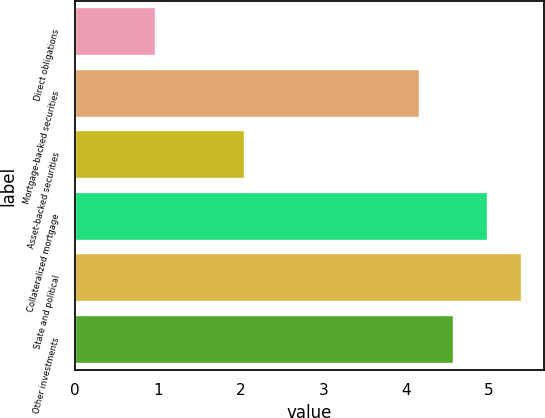Convert chart. <chart><loc_0><loc_0><loc_500><loc_500><bar_chart><fcel>Direct obligations<fcel>Mortgage-backed securities<fcel>Asset-backed securities<fcel>Collateralized mortgage<fcel>State and political<fcel>Other investments<nl><fcel>0.98<fcel>4.17<fcel>2.05<fcel>4.99<fcel>5.4<fcel>4.58<nl></chart> 